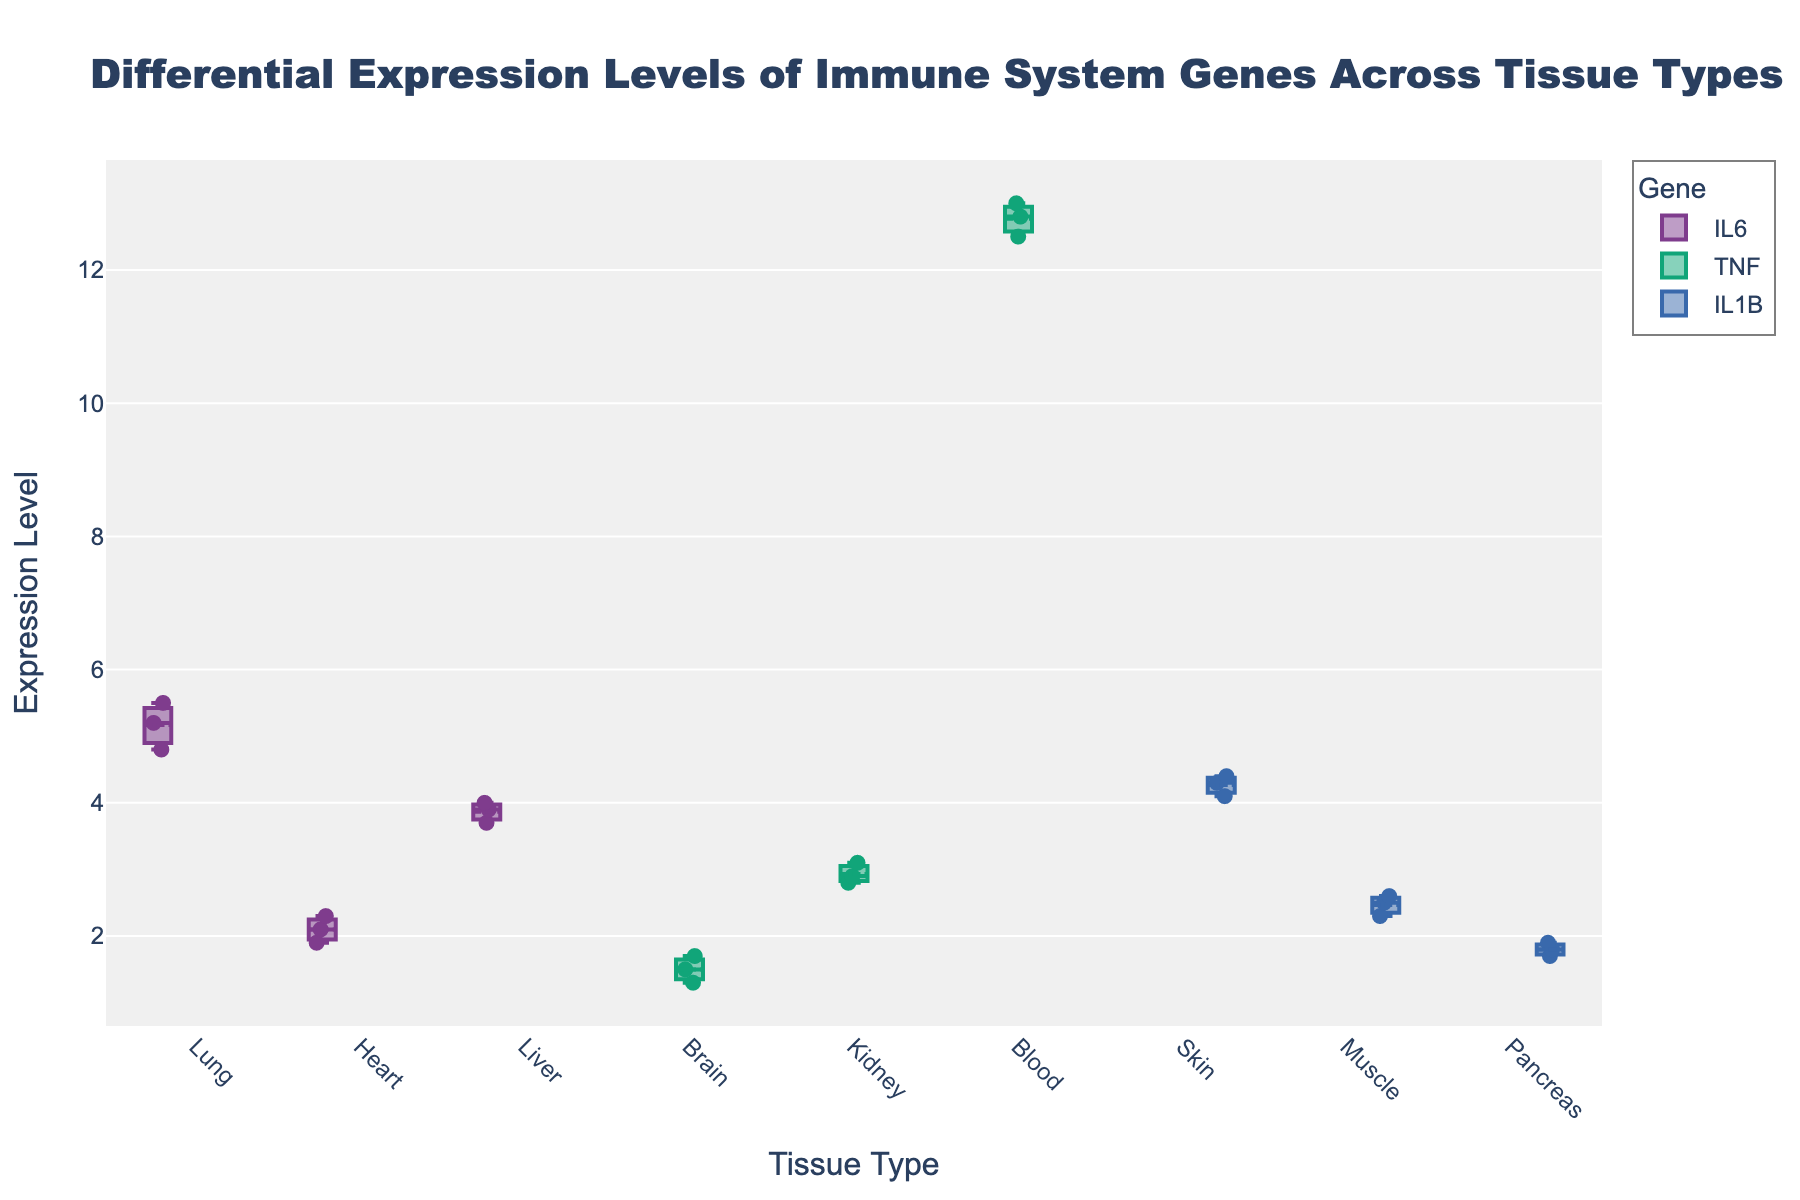What is the title of the plot? The title is usually positioned at the top of the plot, and it provides a summary of what the plot represents. In this plot, the title is clearly visible at the top.
Answer: Differential Expression Levels of Immune System Genes Across Tissue Types Which tissue type has the highest median expression level for the TNF gene? By looking at the TNF gene and analyzing the median point for each tissue type, we notice that Blood has the highest median value.
Answer: Blood What is the expression range (difference between maximum and minimum) for the IL6 gene in the Liver tissue? To find the range, look at the upper and lower whiskers for the IL6 gene in the Liver tissue. The maximum value is about 4.0 and the minimum is about 3.7. The range is 4.0 - 3.7.
Answer: 0.3 How does the median expression level of IL1B in Skin compare to Muscle? Compare the middle lines (medians) of the box plots for IL1B in Skin and Muscle. The median in Skin is higher than in Muscle.
Answer: Higher in Skin Which gene exhibits the widest range of expression levels across any tissue type? Examine the length of the whiskers and the spread of the data points for each tissue type. TNF in Blood has the widest range, as the points are spread out and the whiskers are long.
Answer: TNF in Blood What is the median expression level of IL6 in the Heart tissue? Look at the box plot for IL6 in the Heart tissue and find the line that divides the box into two halves, which represents the median.
Answer: 2.1 Which gene and tissue combination shows the smallest deviation from the median? Observe the width of the boxes and the spread of the data points. IL6 in the Liver appears to have a very tight cluster around the median with little variation.
Answer: IL6 in Liver Is there an outlier in the expression levels of TNF in the Blood tissue? Look for any points that lie outside the whiskers of the box plot for TNF in the Blood tissue. There are no such points, so there are no outliers.
Answer: No What is the mean expression level of the IL1B gene in Muscle tissue? The mean is indicated by a small circle within the box plot. Locate this marker for the IL1B gene in Muscle tissue.
Answer: 2.46 